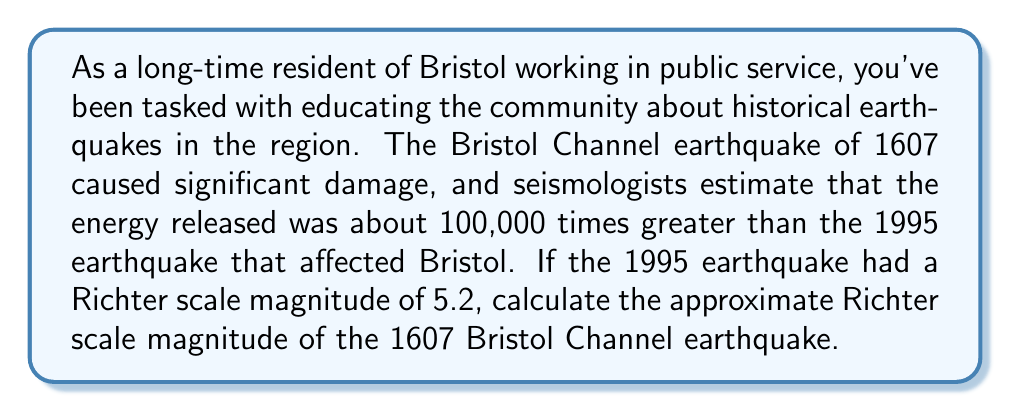Can you solve this math problem? To solve this problem, we'll use the properties of logarithms and the definition of the Richter scale. Let's break it down step-by-step:

1) The Richter scale is logarithmic, based on the formula:
   
   $$ M = \log_{10}\left(\frac{A}{A_0}\right) $$

   Where $M$ is the magnitude, $A$ is the amplitude of the earthquake, and $A_0$ is a standard reference amplitude.

2) We're told that the energy of the 1607 earthquake was 100,000 times greater than the 1995 earthquake. Energy is proportional to the square of the amplitude. So, if we call the amplitude of the 1995 earthquake $A_{1995}$ and the 1607 earthquake $A_{1607}$:

   $$ \left(\frac{A_{1607}}{A_{1995}}\right)^2 = 100,000 $$

3) Taking the square root of both sides:

   $$ \frac{A_{1607}}{A_{1995}} = \sqrt{100,000} = 316.23 $$

4) Now, let's call the magnitude of the 1607 earthquake $M_{1607}$ and the 1995 earthquake $M_{1995}$. We know $M_{1995} = 5.2$.

5) Using the Richter scale formula for both earthquakes and subtracting:

   $$ M_{1607} - M_{1995} = \log_{10}\left(\frac{A_{1607}}{A_0}\right) - \log_{10}\left(\frac{A_{1995}}{A_0}\right) $$

6) Using the logarithm property $\log_a(x) - \log_a(y) = \log_a(\frac{x}{y})$:

   $$ M_{1607} - 5.2 = \log_{10}\left(\frac{A_{1607}}{A_{1995}}\right) $$

7) Substituting the value we found in step 3:

   $$ M_{1607} - 5.2 = \log_{10}(316.23) $$

8) Solving for $M_{1607}$:

   $$ M_{1607} = 5.2 + \log_{10}(316.23) = 5.2 + 2.5 = 7.7 $$

Therefore, the approximate Richter scale magnitude of the 1607 Bristol Channel earthquake was 7.7.
Answer: The approximate Richter scale magnitude of the 1607 Bristol Channel earthquake was 7.7. 